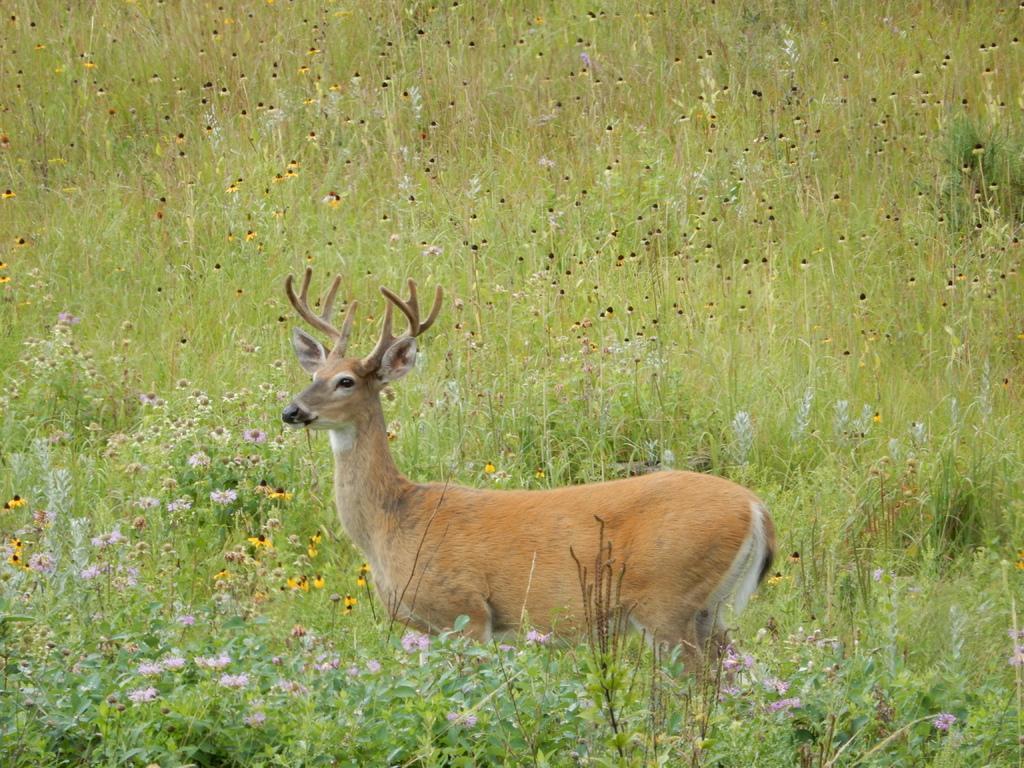Describe this image in one or two sentences. In this image there is full of grass with some small flowers. There is a deer. 